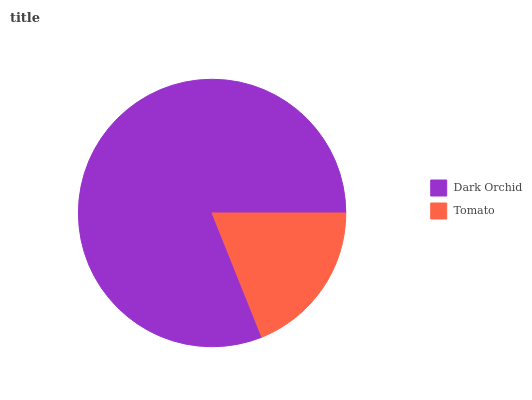Is Tomato the minimum?
Answer yes or no. Yes. Is Dark Orchid the maximum?
Answer yes or no. Yes. Is Tomato the maximum?
Answer yes or no. No. Is Dark Orchid greater than Tomato?
Answer yes or no. Yes. Is Tomato less than Dark Orchid?
Answer yes or no. Yes. Is Tomato greater than Dark Orchid?
Answer yes or no. No. Is Dark Orchid less than Tomato?
Answer yes or no. No. Is Dark Orchid the high median?
Answer yes or no. Yes. Is Tomato the low median?
Answer yes or no. Yes. Is Tomato the high median?
Answer yes or no. No. Is Dark Orchid the low median?
Answer yes or no. No. 